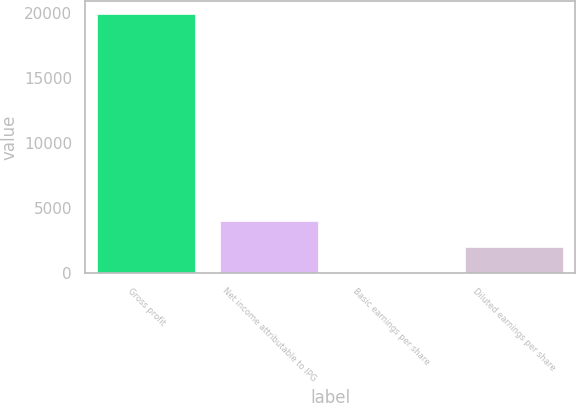Convert chart. <chart><loc_0><loc_0><loc_500><loc_500><bar_chart><fcel>Gross profit<fcel>Net income attributable to IPG<fcel>Basic earnings per share<fcel>Diluted earnings per share<nl><fcel>19912<fcel>3982.45<fcel>0.07<fcel>1991.26<nl></chart> 